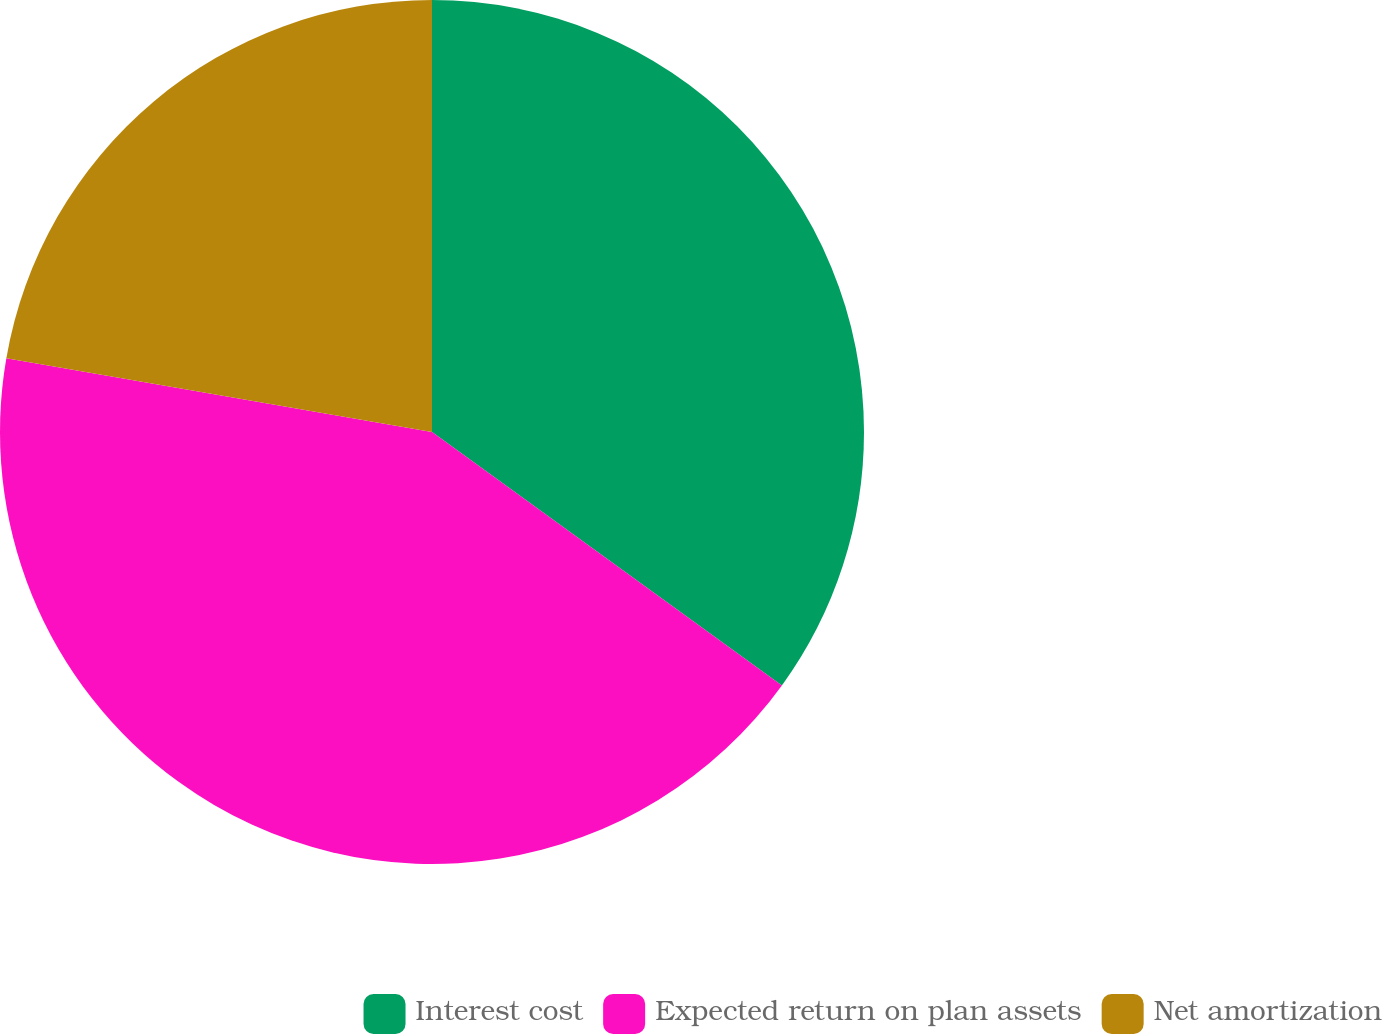Convert chart to OTSL. <chart><loc_0><loc_0><loc_500><loc_500><pie_chart><fcel>Interest cost<fcel>Expected return on plan assets<fcel>Net amortization<nl><fcel>34.98%<fcel>42.76%<fcel>22.27%<nl></chart> 